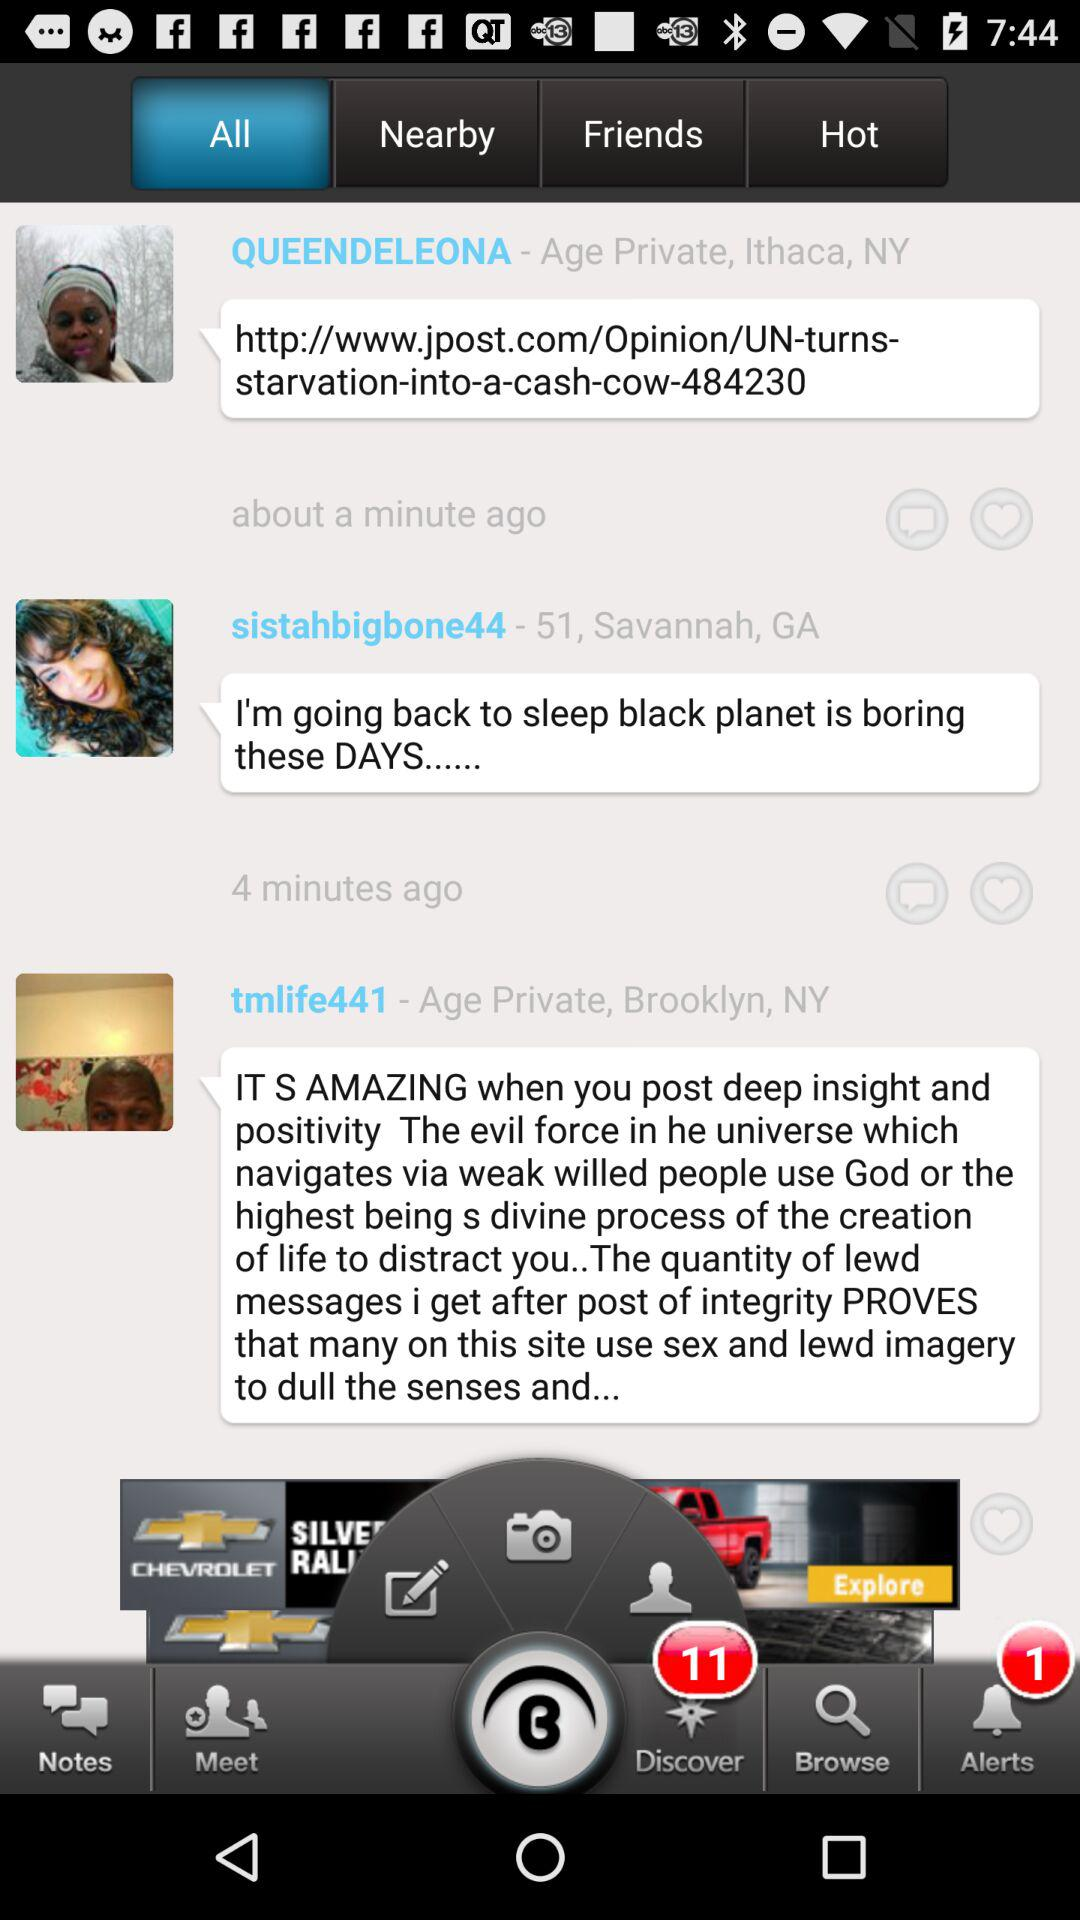What is the age of "sistahbigbone44"? The age of "sistahbigbone44" is 51. 